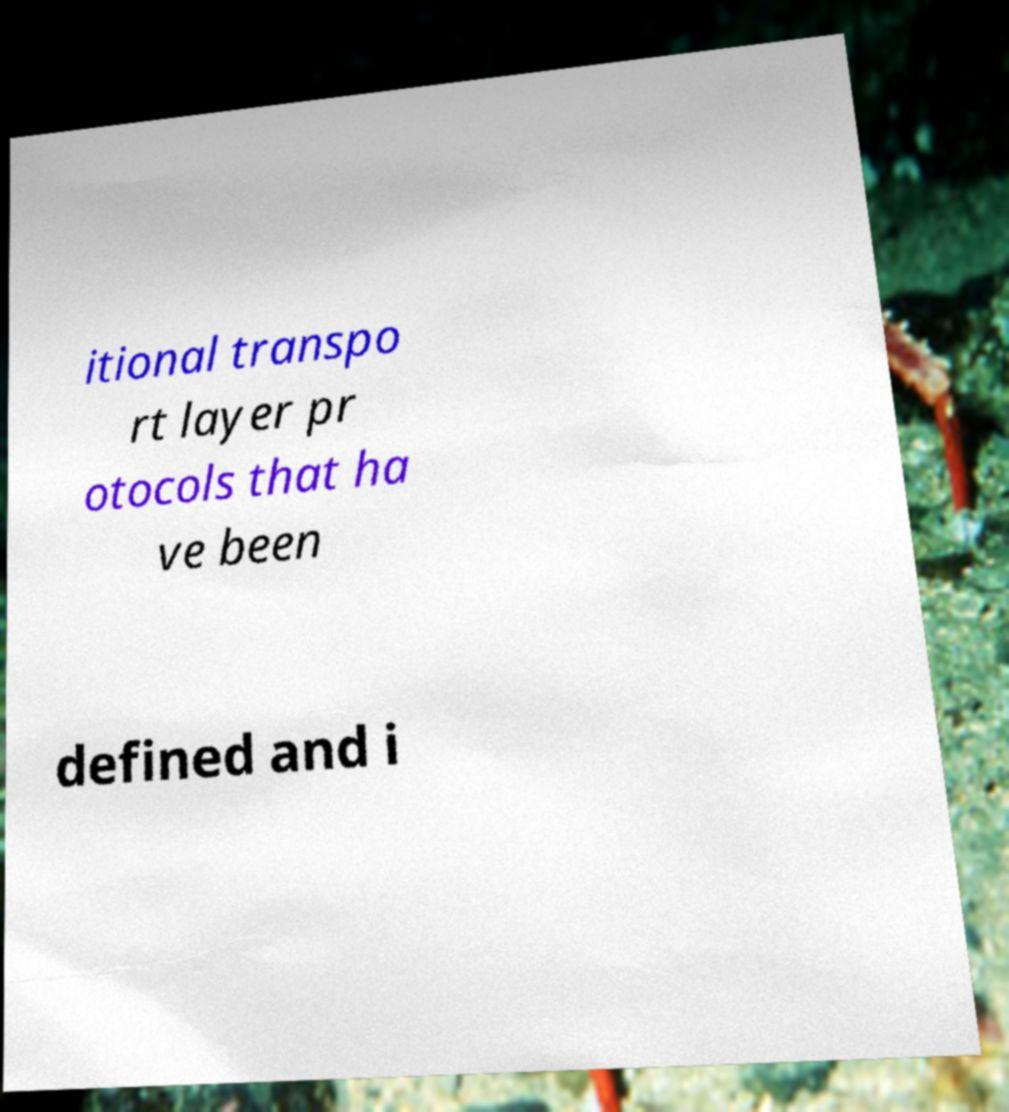Could you assist in decoding the text presented in this image and type it out clearly? itional transpo rt layer pr otocols that ha ve been defined and i 